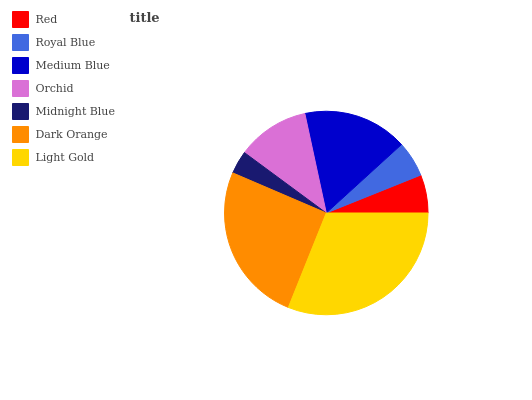Is Midnight Blue the minimum?
Answer yes or no. Yes. Is Light Gold the maximum?
Answer yes or no. Yes. Is Royal Blue the minimum?
Answer yes or no. No. Is Royal Blue the maximum?
Answer yes or no. No. Is Red greater than Royal Blue?
Answer yes or no. Yes. Is Royal Blue less than Red?
Answer yes or no. Yes. Is Royal Blue greater than Red?
Answer yes or no. No. Is Red less than Royal Blue?
Answer yes or no. No. Is Orchid the high median?
Answer yes or no. Yes. Is Orchid the low median?
Answer yes or no. Yes. Is Royal Blue the high median?
Answer yes or no. No. Is Dark Orange the low median?
Answer yes or no. No. 